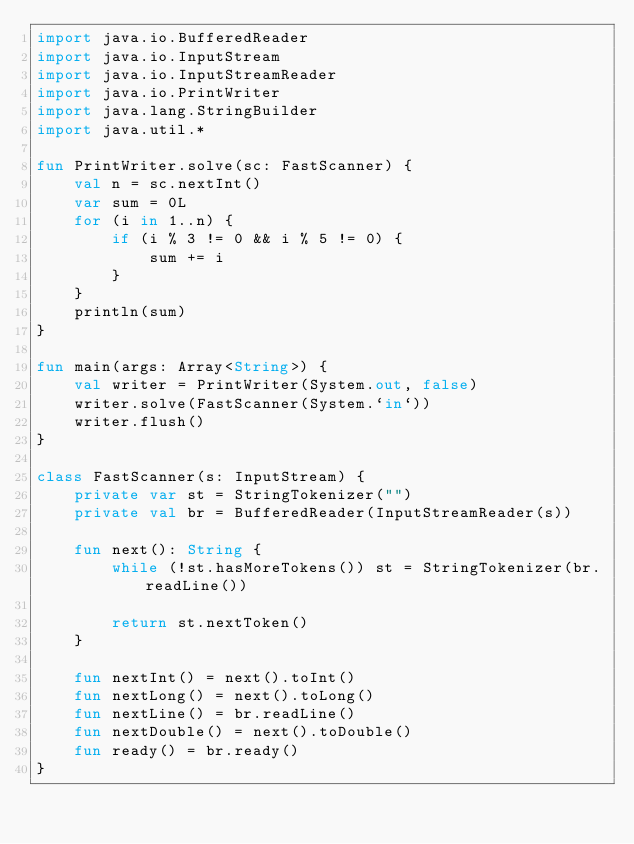<code> <loc_0><loc_0><loc_500><loc_500><_Kotlin_>import java.io.BufferedReader
import java.io.InputStream
import java.io.InputStreamReader
import java.io.PrintWriter
import java.lang.StringBuilder
import java.util.*

fun PrintWriter.solve(sc: FastScanner) {
    val n = sc.nextInt()
    var sum = 0L
    for (i in 1..n) {
        if (i % 3 != 0 && i % 5 != 0) {
            sum += i
        }
    }
    println(sum)
}

fun main(args: Array<String>) {
    val writer = PrintWriter(System.out, false)
    writer.solve(FastScanner(System.`in`))
    writer.flush()
}

class FastScanner(s: InputStream) {
    private var st = StringTokenizer("")
    private val br = BufferedReader(InputStreamReader(s))

    fun next(): String {
        while (!st.hasMoreTokens()) st = StringTokenizer(br.readLine())

        return st.nextToken()
    }

    fun nextInt() = next().toInt()
    fun nextLong() = next().toLong()
    fun nextLine() = br.readLine()
    fun nextDouble() = next().toDouble()
    fun ready() = br.ready()
}
</code> 